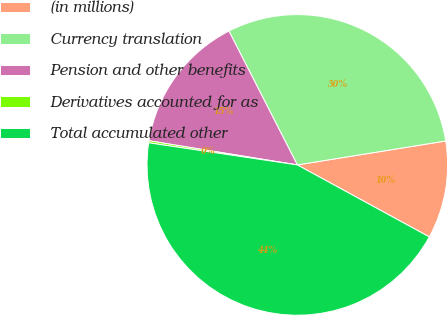<chart> <loc_0><loc_0><loc_500><loc_500><pie_chart><fcel>(in millions)<fcel>Currency translation<fcel>Pension and other benefits<fcel>Derivatives accounted for as<fcel>Total accumulated other<nl><fcel>10.49%<fcel>29.97%<fcel>14.91%<fcel>0.22%<fcel>44.4%<nl></chart> 